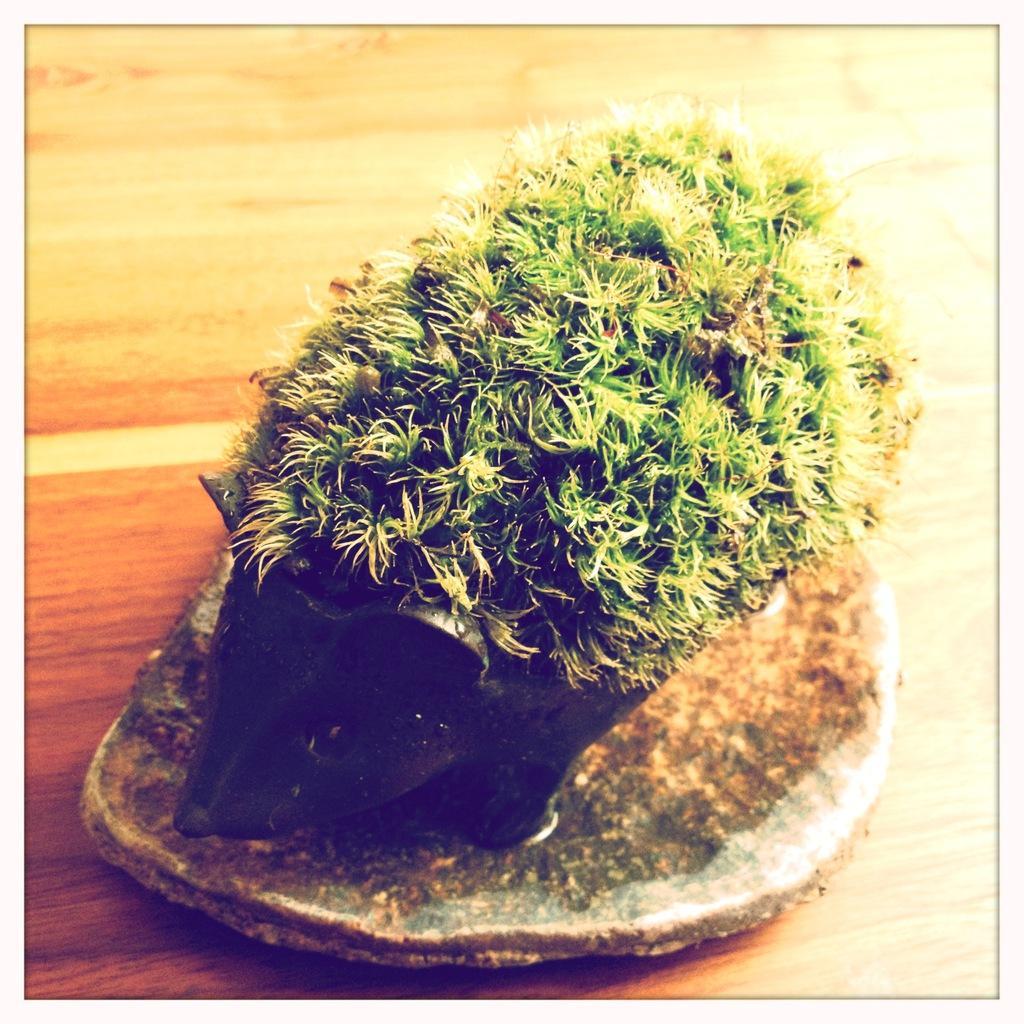How would you summarize this image in a sentence or two? In this image I can see a plant in the black colour pot. Under the pot I can see brown colour surface. 